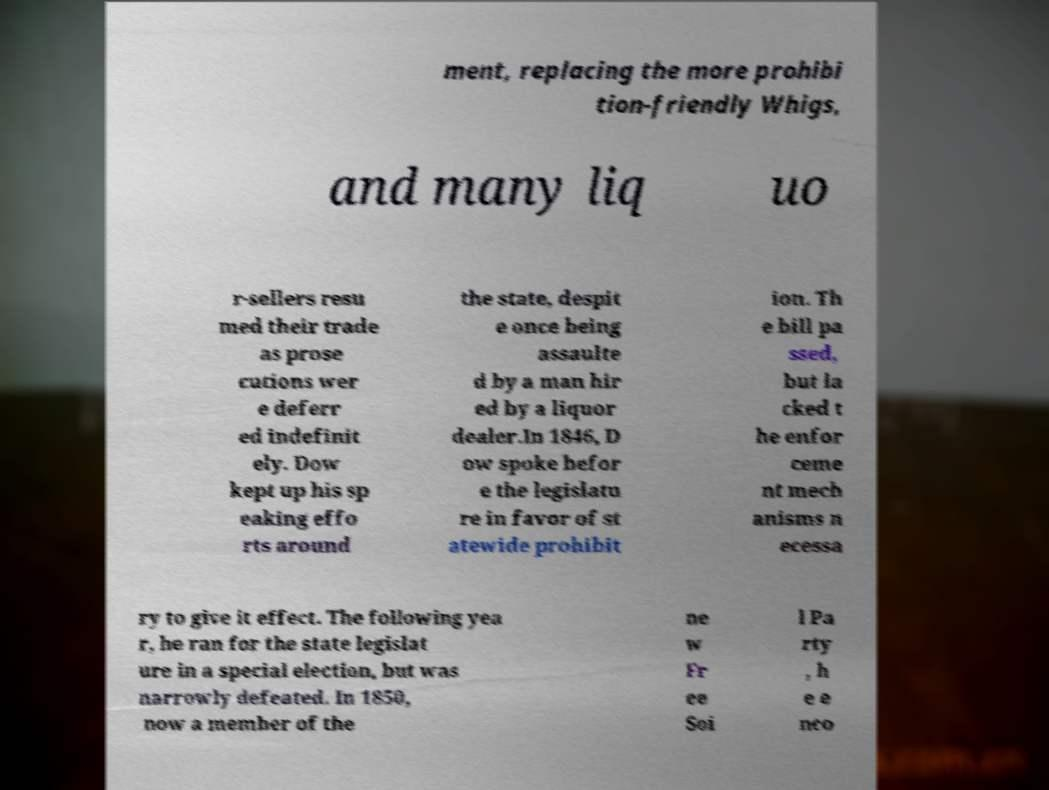What messages or text are displayed in this image? I need them in a readable, typed format. ment, replacing the more prohibi tion-friendly Whigs, and many liq uo r-sellers resu med their trade as prose cutions wer e deferr ed indefinit ely. Dow kept up his sp eaking effo rts around the state, despit e once being assaulte d by a man hir ed by a liquor dealer.In 1846, D ow spoke befor e the legislatu re in favor of st atewide prohibit ion. Th e bill pa ssed, but la cked t he enfor ceme nt mech anisms n ecessa ry to give it effect. The following yea r, he ran for the state legislat ure in a special election, but was narrowly defeated. In 1850, now a member of the ne w Fr ee Soi l Pa rty , h e e nco 